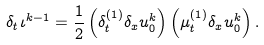<formula> <loc_0><loc_0><loc_500><loc_500>\delta _ { t } \iota ^ { k - 1 } = \frac { 1 } { 2 } \left ( \delta _ { t } ^ { ( 1 ) } \delta _ { x } u _ { 0 } ^ { k } \right ) \left ( \mu _ { t } ^ { ( 1 ) } \delta _ { x } u _ { 0 } ^ { k } \right ) .</formula> 